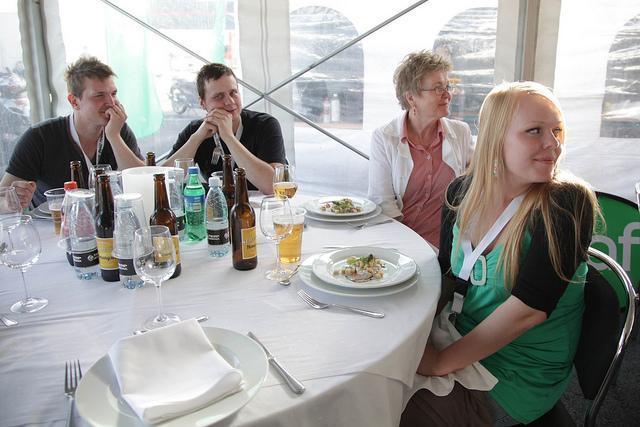How many people are sitting at the table in this picture?
Give a very brief answer. 4. How many bottles can be seen?
Give a very brief answer. 3. How many wine glasses are there?
Give a very brief answer. 2. How many people are there?
Give a very brief answer. 4. How many chairs are there?
Give a very brief answer. 1. 